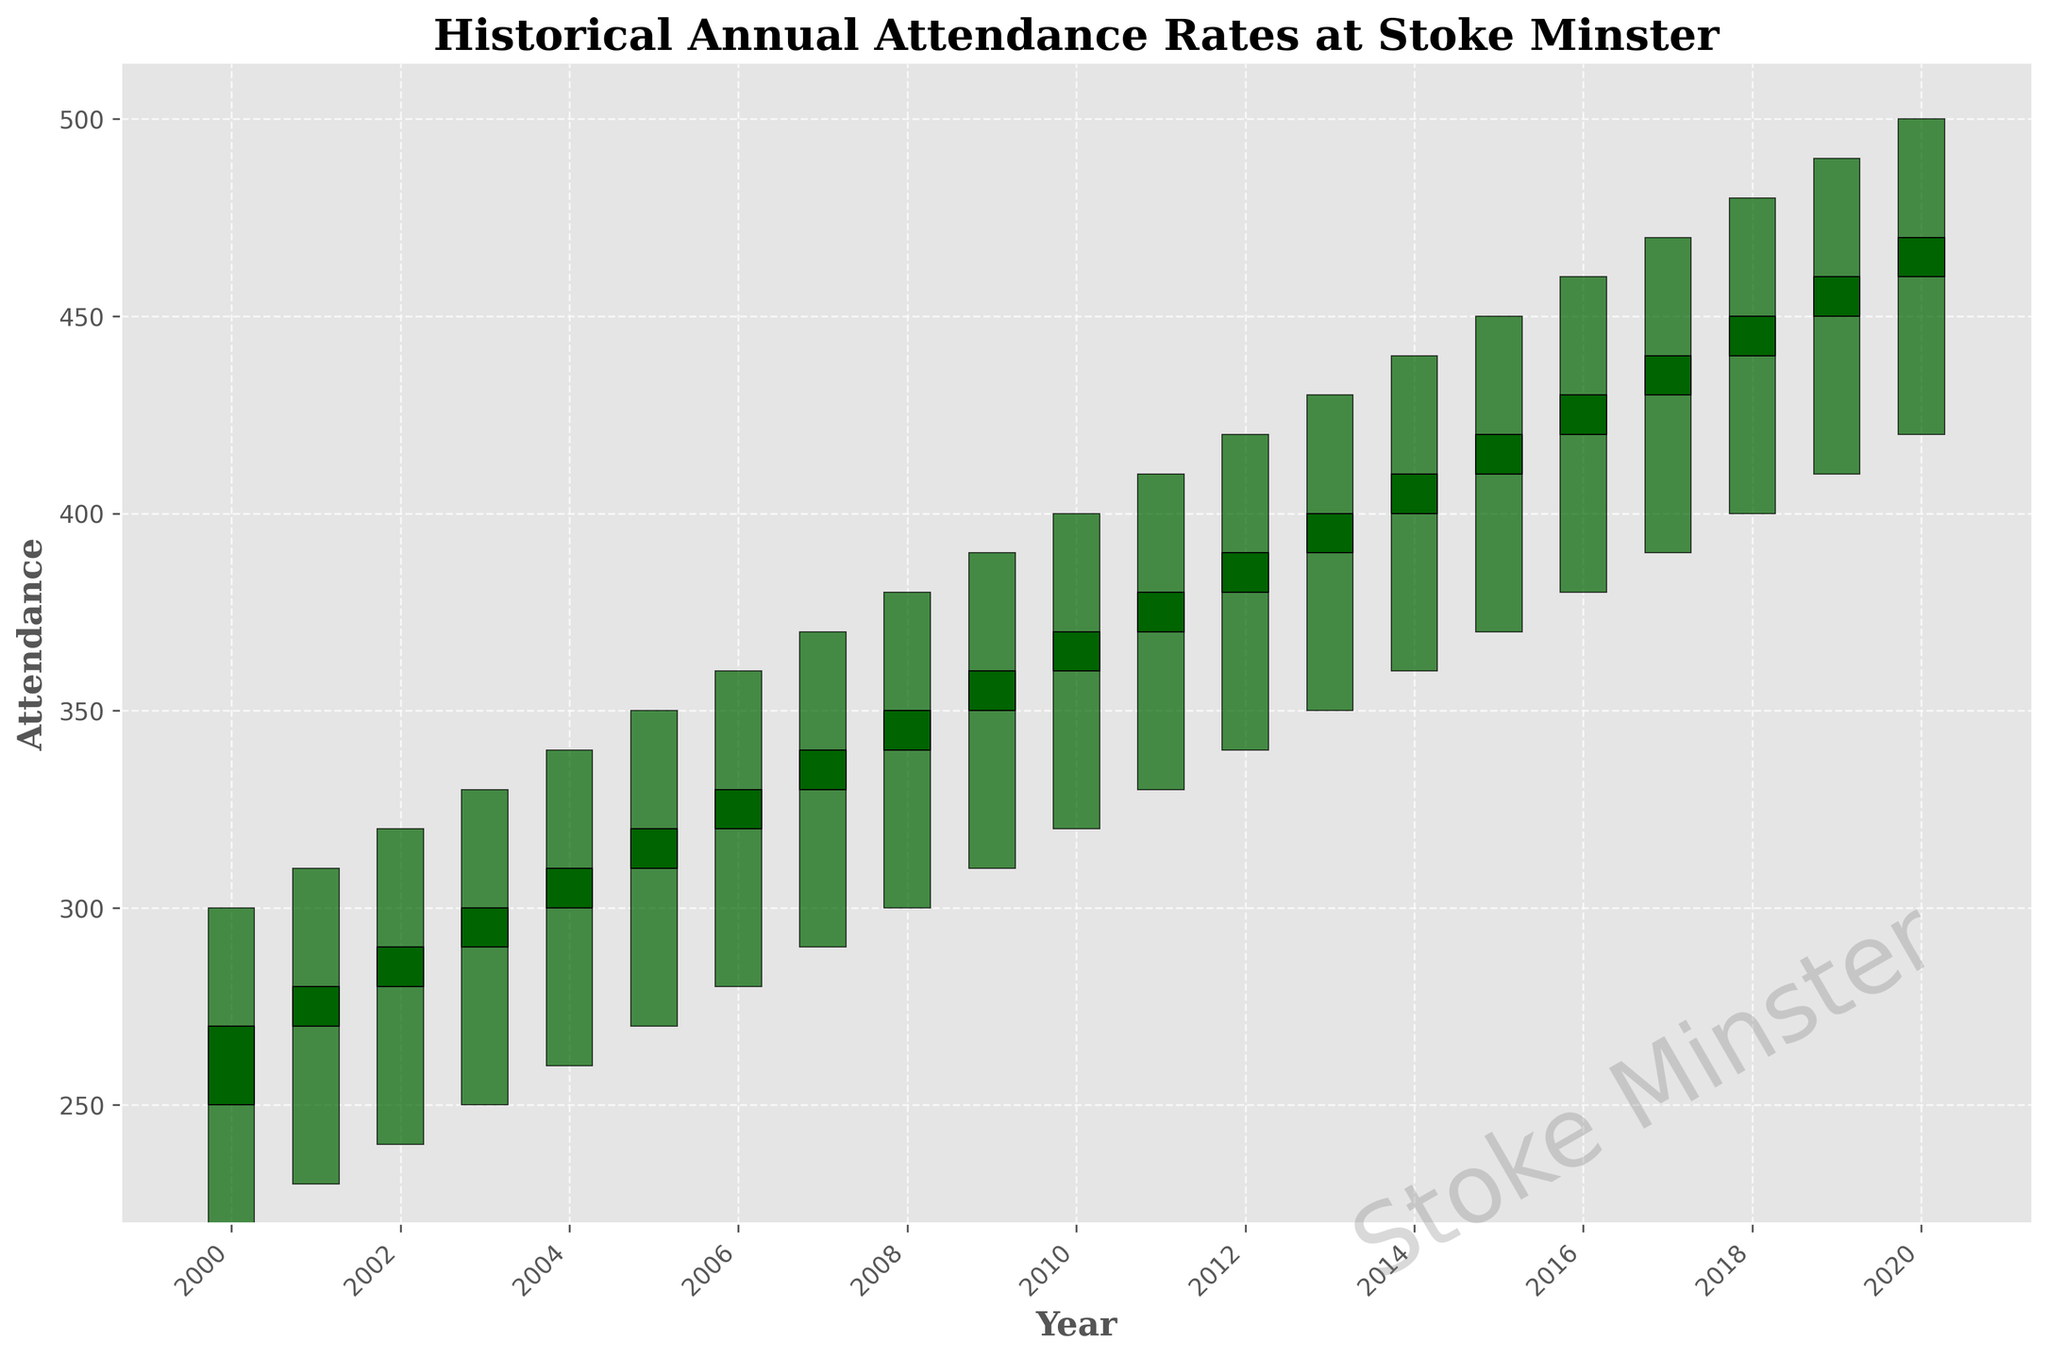What is the title of the plot? The title of the plot is displayed at the top and it reads "Historical Annual Attendance Rates at Stoke Minster".
Answer: Historical Annual Attendance Rates at Stoke Minster How many years of data are shown in the figure? By counting the discrete data points along the x-axis, each representing a year from 2000 to 2020, we can see there are 21 years of data.
Answer: 21 In which year did the attendance have the highest closing value? The closing values are represented by the tops of the filled candlesticks. The highest closing value, 470, is observed in the year 2020.
Answer: 2020 From which year to which year does the plot display increasing trend in attendance solely based on the closing values? Observing the closing values at the tops of the candlesticks, we can see an uninterrupted increase from the year 2000 (closing at 270) to 2020 (closing at 470).
Answer: 2000 to 2020 What was the difference between the highest and lowest attendance in 2006? In 2006, the highest attendance was 360 and the lowest was 280. The difference is calculated as 360 - 280, which equals 80.
Answer: 80 Which years experienced a decrease in the closing attendance compared to the opening attendance? The candlestick bars filled in dark red indicate years where the closing value is lower than the opening value. There are no red candlestick bars, indicating no years with such a decrease.
Answer: None What was the range of attendance in 2018? The range is determined by subtracting the lowest value from the highest value in 2018. This is calculated as 480 - 400, equaling 80.
Answer: 80 Between which consecutive years was the largest increase in closing attendance observed? By comparing the closing values year by year, the largest increase is from 460 in 2019 to 470 in 2020, with an increase of 10.
Answer: 2019 to 2020 What color represents the years where the closing attendance is higher than the opening attendance? The candlestick bars filled in dark green indicate years where the closing value is higher than the opening value.
Answer: Dark green In which year did the attendance open at 300? According to the data, the opening value of 300 is in the year 2004.
Answer: 2004 